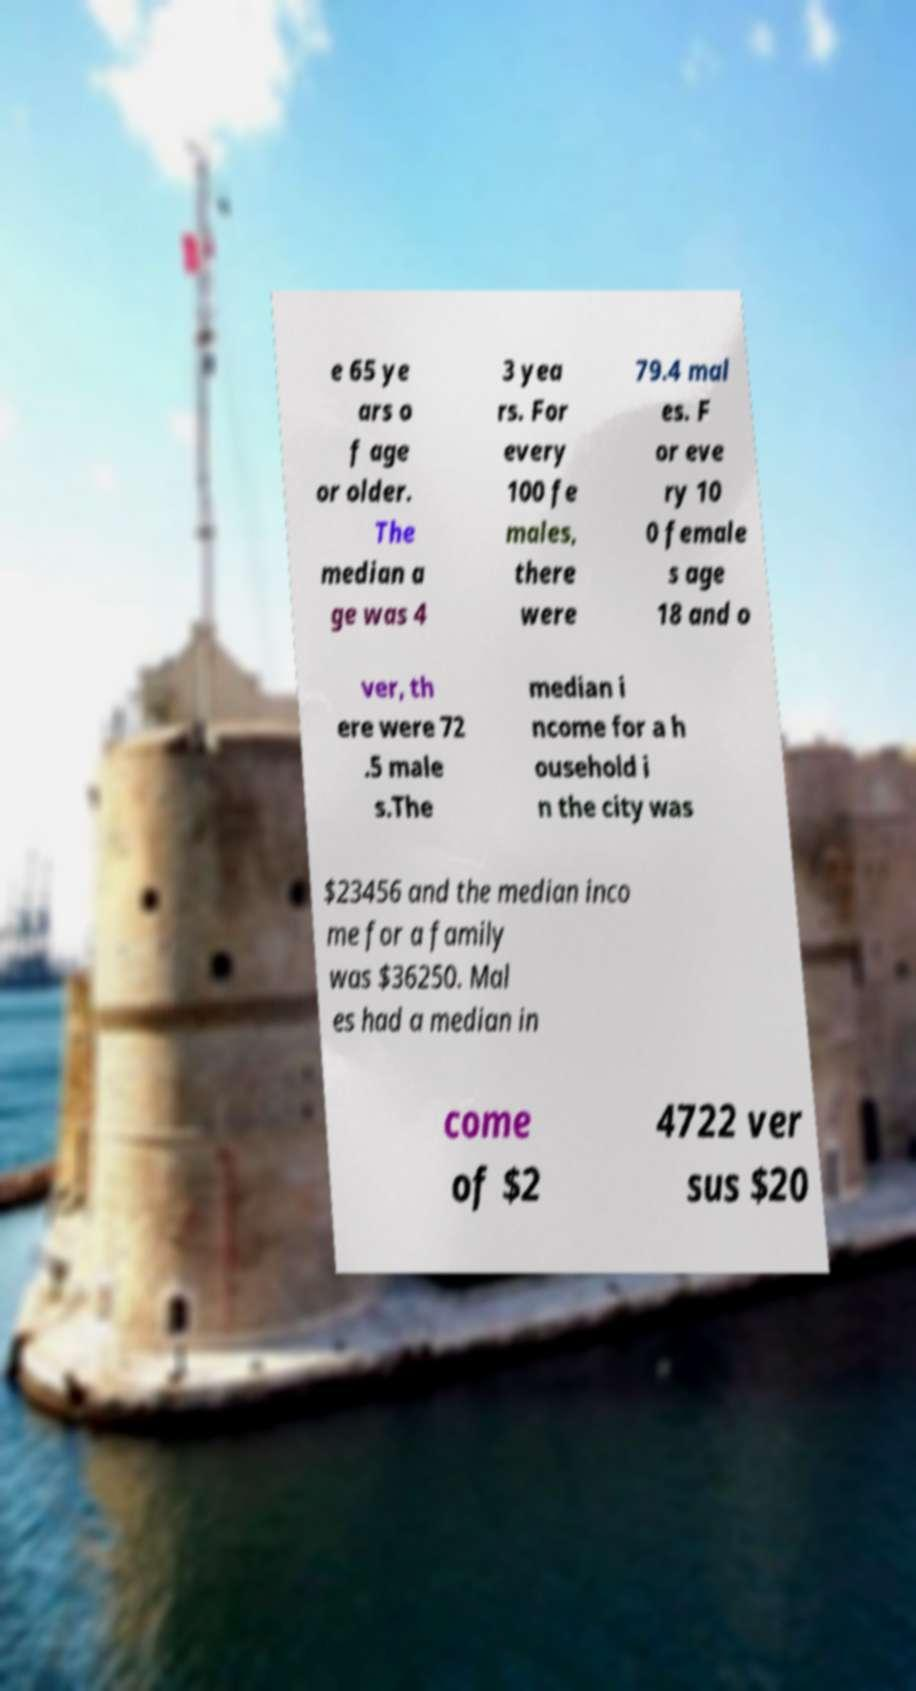I need the written content from this picture converted into text. Can you do that? e 65 ye ars o f age or older. The median a ge was 4 3 yea rs. For every 100 fe males, there were 79.4 mal es. F or eve ry 10 0 female s age 18 and o ver, th ere were 72 .5 male s.The median i ncome for a h ousehold i n the city was $23456 and the median inco me for a family was $36250. Mal es had a median in come of $2 4722 ver sus $20 